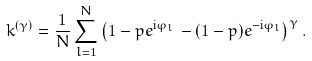<formula> <loc_0><loc_0><loc_500><loc_500>k ^ { ( \gamma ) } = \frac { 1 } { N } \sum _ { l = 1 } ^ { N } \left ( 1 - p e ^ { \text {i} \varphi _ { l } \, } - ( 1 - p ) e ^ { - \text {i} \varphi _ { l } } \right ) ^ { \gamma } .</formula> 